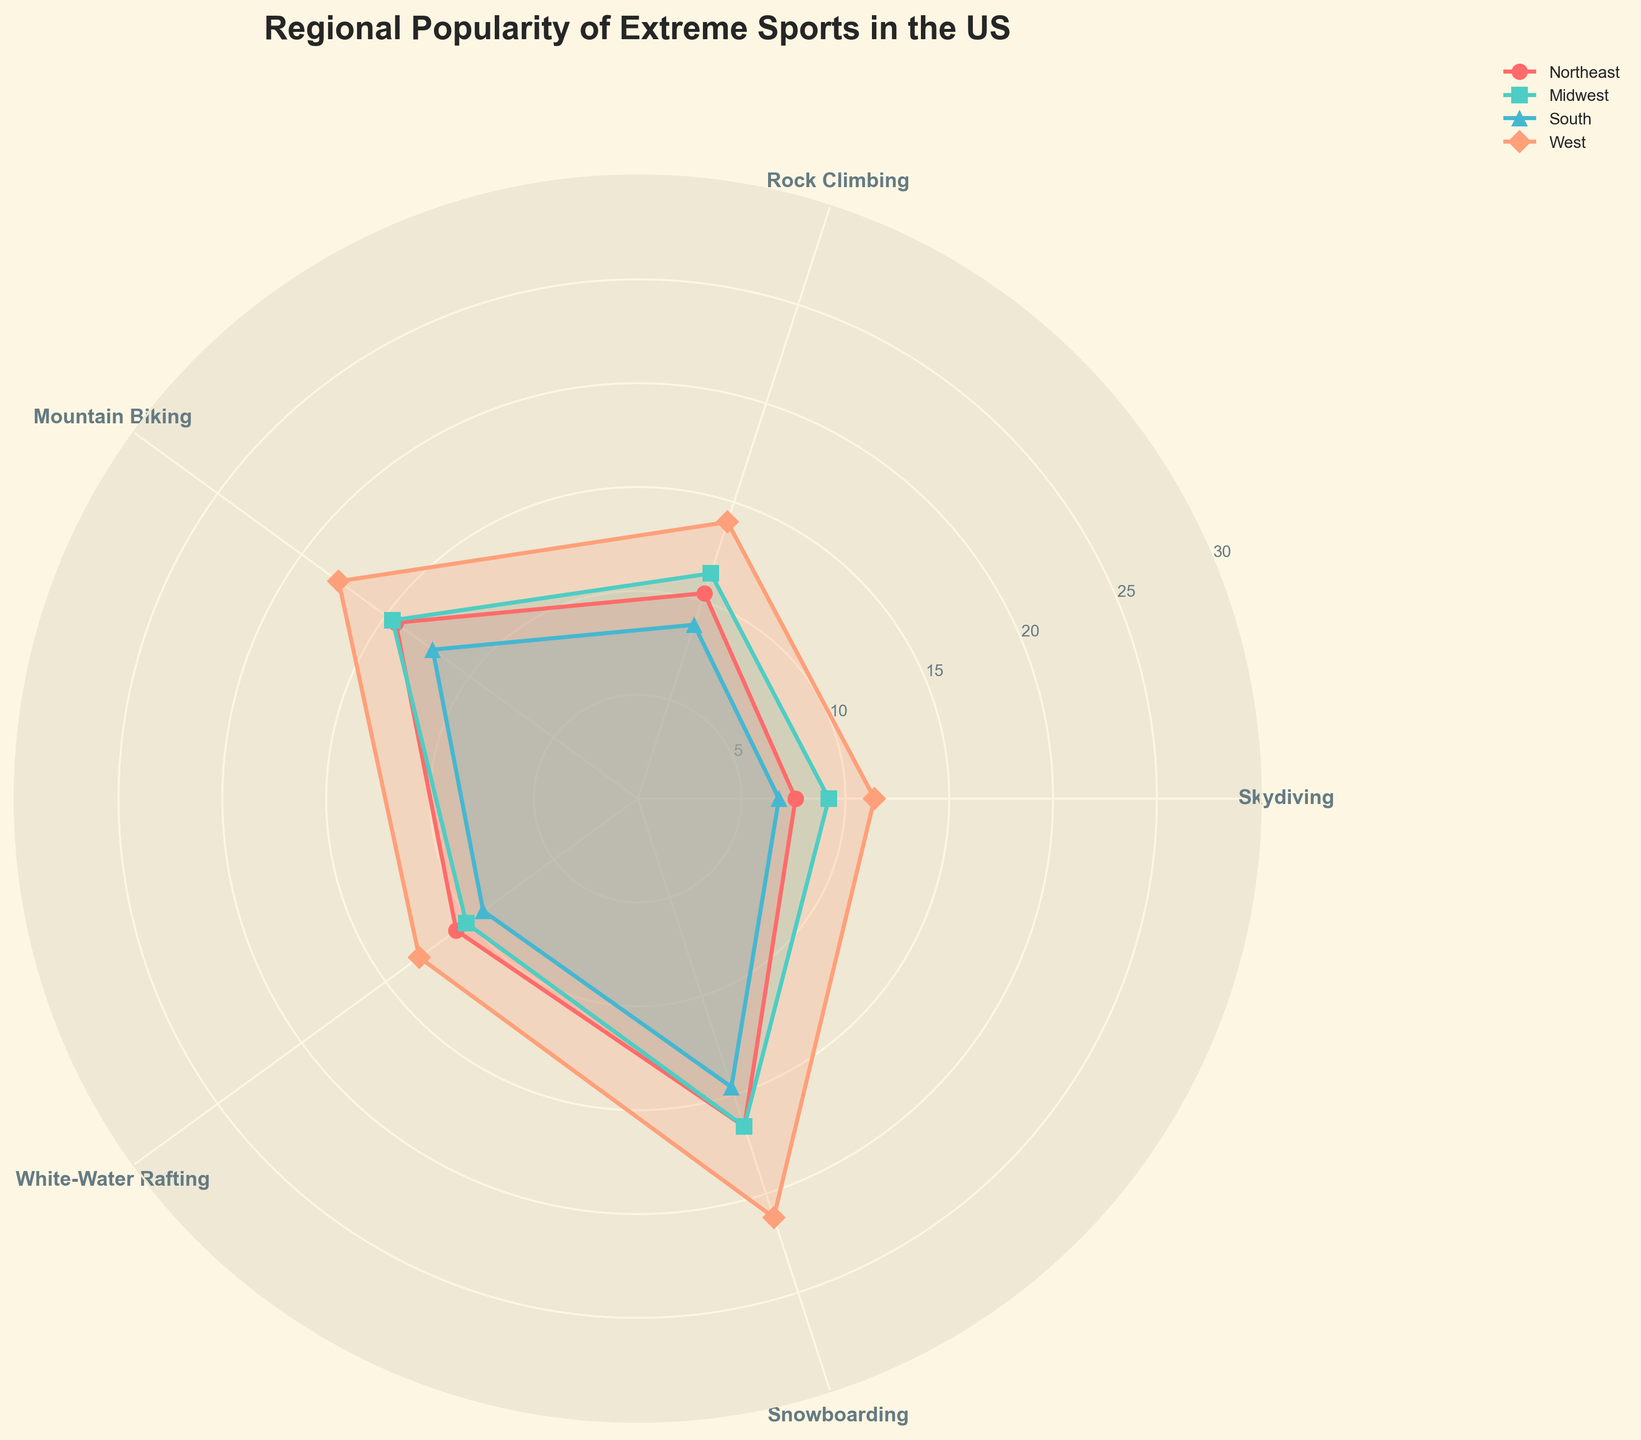What is the title of the plot? The title is written in bold at the top of the plot. By reading it, we can easily see the title is: "Regional Popularity of Extreme Sports in the US".
Answer: Regional Popularity of Extreme Sports in the US How many regions are represented in the plot? By looking at the legend in the plot, we can count the number of regions listed, which are four: Northeast, Midwest, South, and West.
Answer: Four Which sport is most popular in the West among the 25-34 age group? Looking at the data for the West region and the age group 25-34, we see the highest value is 28 for Snowboarding.
Answer: Snowboarding Which age group in the Northeast has the highest average participation across all sports? By calculating the average for each age group in the Northeast: 18-24: (8+12+15+10+18)/5 = 12.6, 25-34: (14+15+20+16+22)/5 = 17.4, 35-44: (10+12+18+14+20)/5 = 14.8, 45-54: (4+8+12+9+15)/5 = 9.6, 55+: (2+5+7+5+8)/5 = 5.4. The highest average is for the 25-34 age group.
Answer: 25-34 Which region has the highest average popularity for Mountain Biking? Looking at the data for Mountain Biking: Northeast: (15+20+18+12+7)/5 = 14.4, Midwest: (19+22+16+10+6)/5 = 14.6, South: (14+18+15+10+4)/5 = 12.2, West: (22+26+20+13+8)/5 = 17.8. The West has the highest average.
Answer: West Which age group in the Midwest shows the lowest participation in Rock Climbing? The data for Rock Climbing in the Midwest shows the following values: 18-24: 15, 25-34: 18, 35-44: 13, 45-54: 7, 55+: 4. The lowest participation is in the 55+ age group.
Answer: 55+ What's the difference in average popularity of White-Water Rafting between the Northeast and South? Calculating the averages: Northeast: (10+16+14+9+5)/5 = 10.8, South: (11+13+12+7+3)/5 = 9.2. The difference is 10.8 - 9.2 = 1.6.
Answer: 1.6 Which activity shows the most notable regional difference in popularity for the 18-24 age group? Observing the values across regions for 18-24 age group: Skydiving: 8, 10, 7, 12; Rock Climbing: 12, 15, 10, 18; Mountain Biking: 15, 19, 14, 22; White-Water Rafting: 10, 12, 11, 15; Snowboarding: 18, 20, 16, 25. Snowboarding shows the highest range (25 - 16 = 9).
Answer: Snowboarding Which region's 35-44 age group has the highest popularity for Skydiving and Snowboarding combined? Summing the values for Skydiving and Snowboarding for the 35-44 age group: Northeast: 10+20=30, Midwest: 11+18=29, South: 9+17=26, West: 14+24=38. The West region has the highest combined popularity.
Answer: West How do the Midwest and Northeast compare in terms of the average popularity of all sports across all age groups? Calculating the averages for each region's values across all age groups and sports: Northeast: 195/5/5 = 7.8, Midwest: 218/5/5 = 8.72. The Midwest has a higher average.
Answer: Midwest 